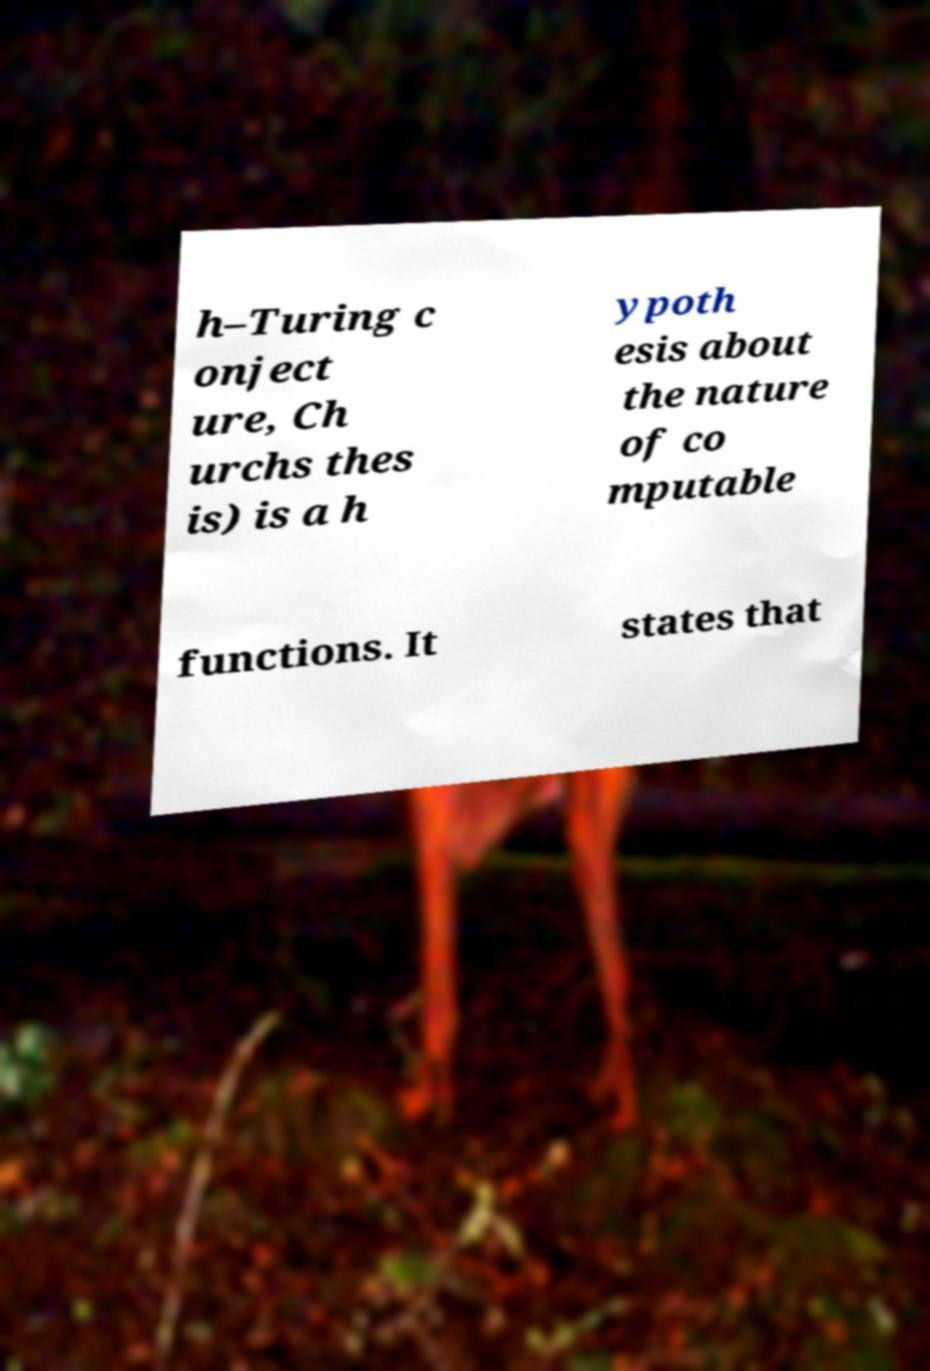Please read and relay the text visible in this image. What does it say? h–Turing c onject ure, Ch urchs thes is) is a h ypoth esis about the nature of co mputable functions. It states that 